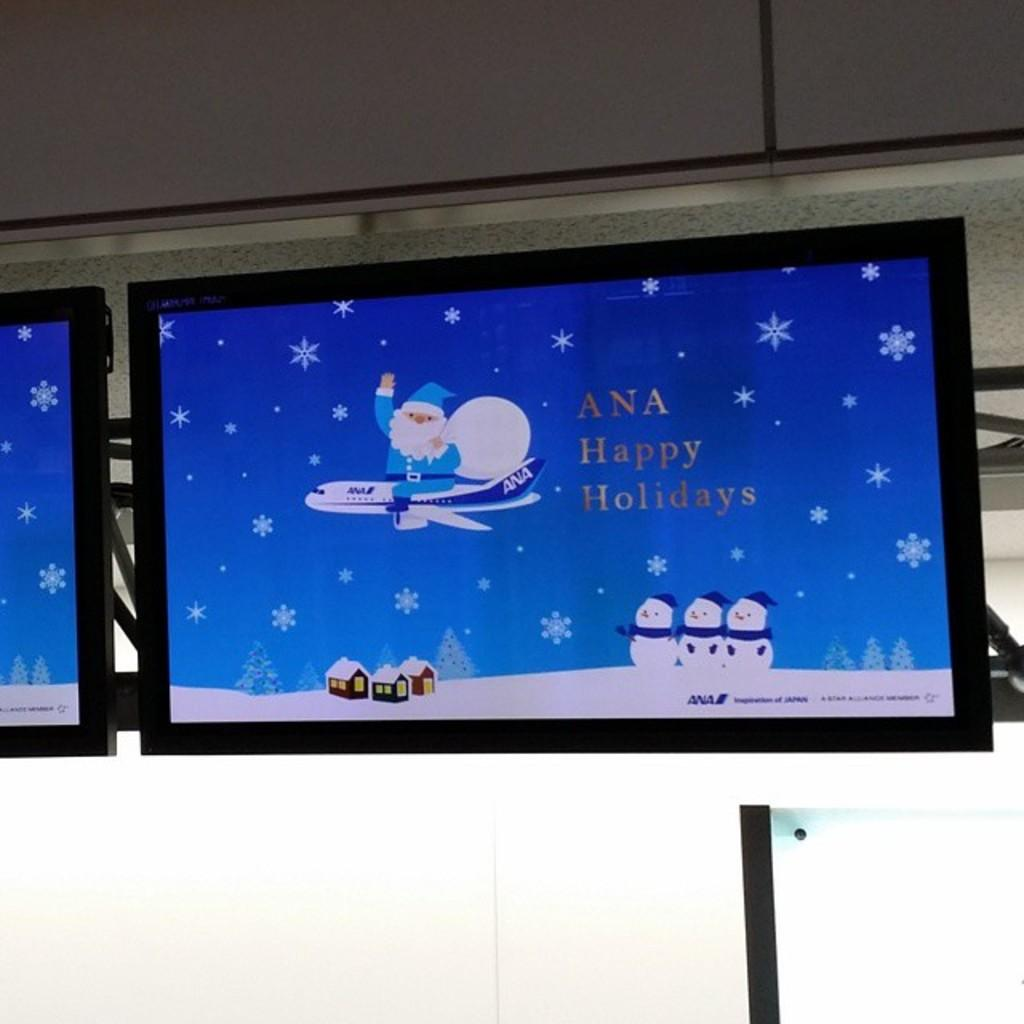<image>
Provide a brief description of the given image. a happy holidays sign that is in a room 